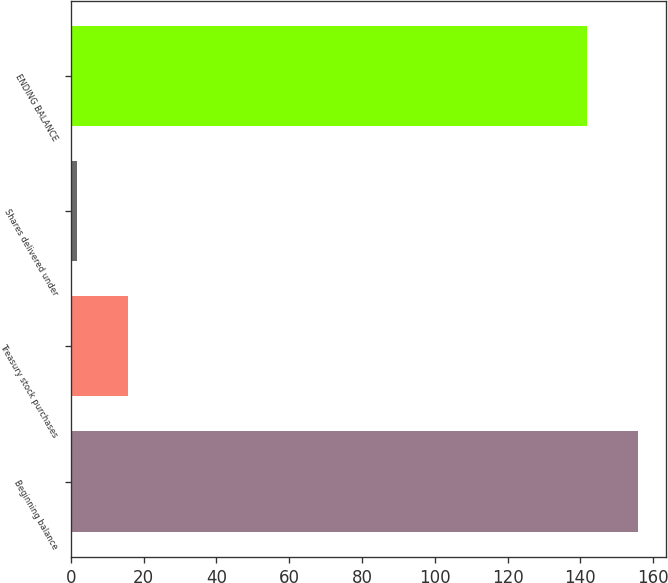Convert chart to OTSL. <chart><loc_0><loc_0><loc_500><loc_500><bar_chart><fcel>Beginning balance<fcel>Treasury stock purchases<fcel>Shares delivered under<fcel>ENDING BALANCE<nl><fcel>155.73<fcel>15.83<fcel>1.8<fcel>141.7<nl></chart> 